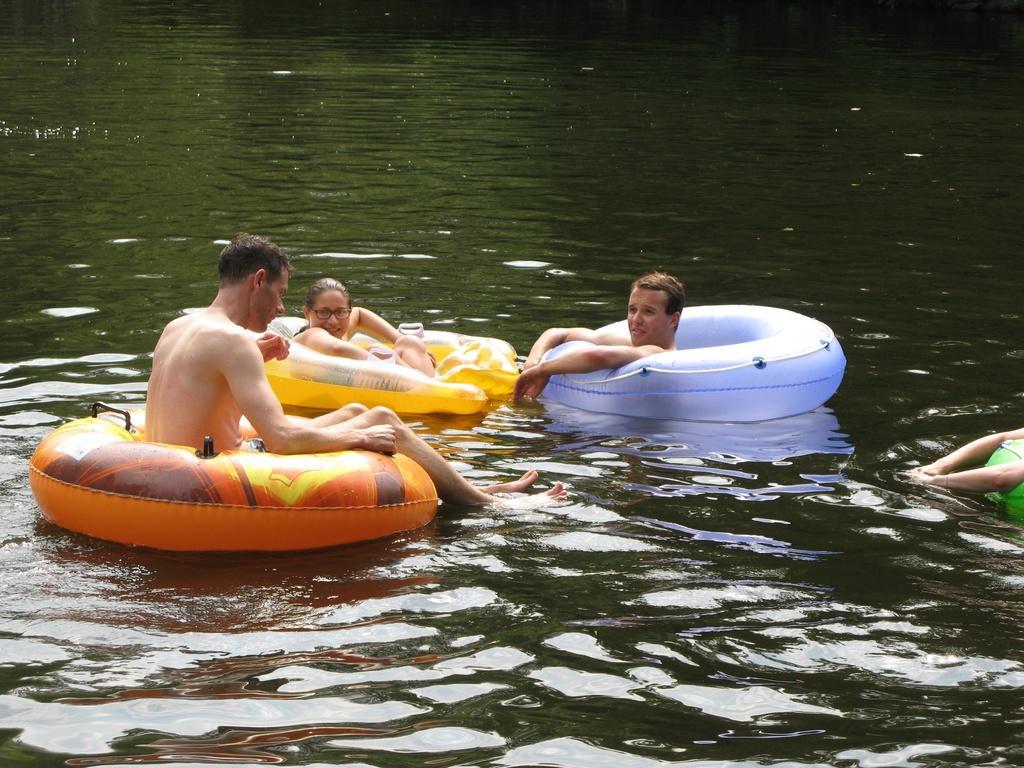Please provide a concise description of this image. In this is water. There are tubes. There are people swimming.. 